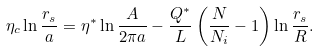<formula> <loc_0><loc_0><loc_500><loc_500>\eta _ { c } \ln \frac { r _ { s } } { a } = \eta ^ { * } \ln \frac { A } { 2 \pi a } - \frac { Q ^ { * } } { L } \left ( \frac { N } { N _ { i } } - 1 \right ) \ln \frac { r _ { s } } { R } .</formula> 